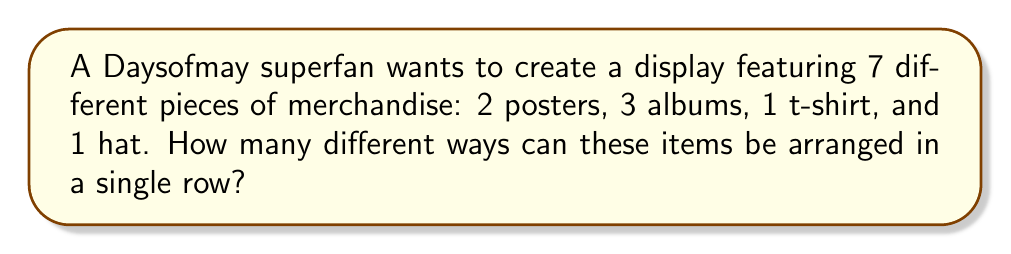Give your solution to this math problem. To solve this problem, we need to use the concept of permutations. Since we have 7 distinct items and we want to arrange all of them, this is a straightforward permutation problem.

The formula for permutations of n distinct objects is:

$$P(n) = n!$$

Where $n!$ represents the factorial of $n$.

In this case, we have 7 distinct items (2 posters, 3 albums, 1 t-shirt, and 1 hat), so $n = 7$.

Therefore, the number of ways to arrange these items is:

$$P(7) = 7!$$

Calculating this:

$$\begin{align*}
7! &= 7 \times 6 \times 5 \times 4 \times 3 \times 2 \times 1 \\
   &= 5040
\end{align*}$$

It's important to note that even though there are multiple posters and albums, each item is considered distinct in this arrangement. For example, the two posters could be from different tours or have different designs, making each one unique in the display.
Answer: $5040$ ways 